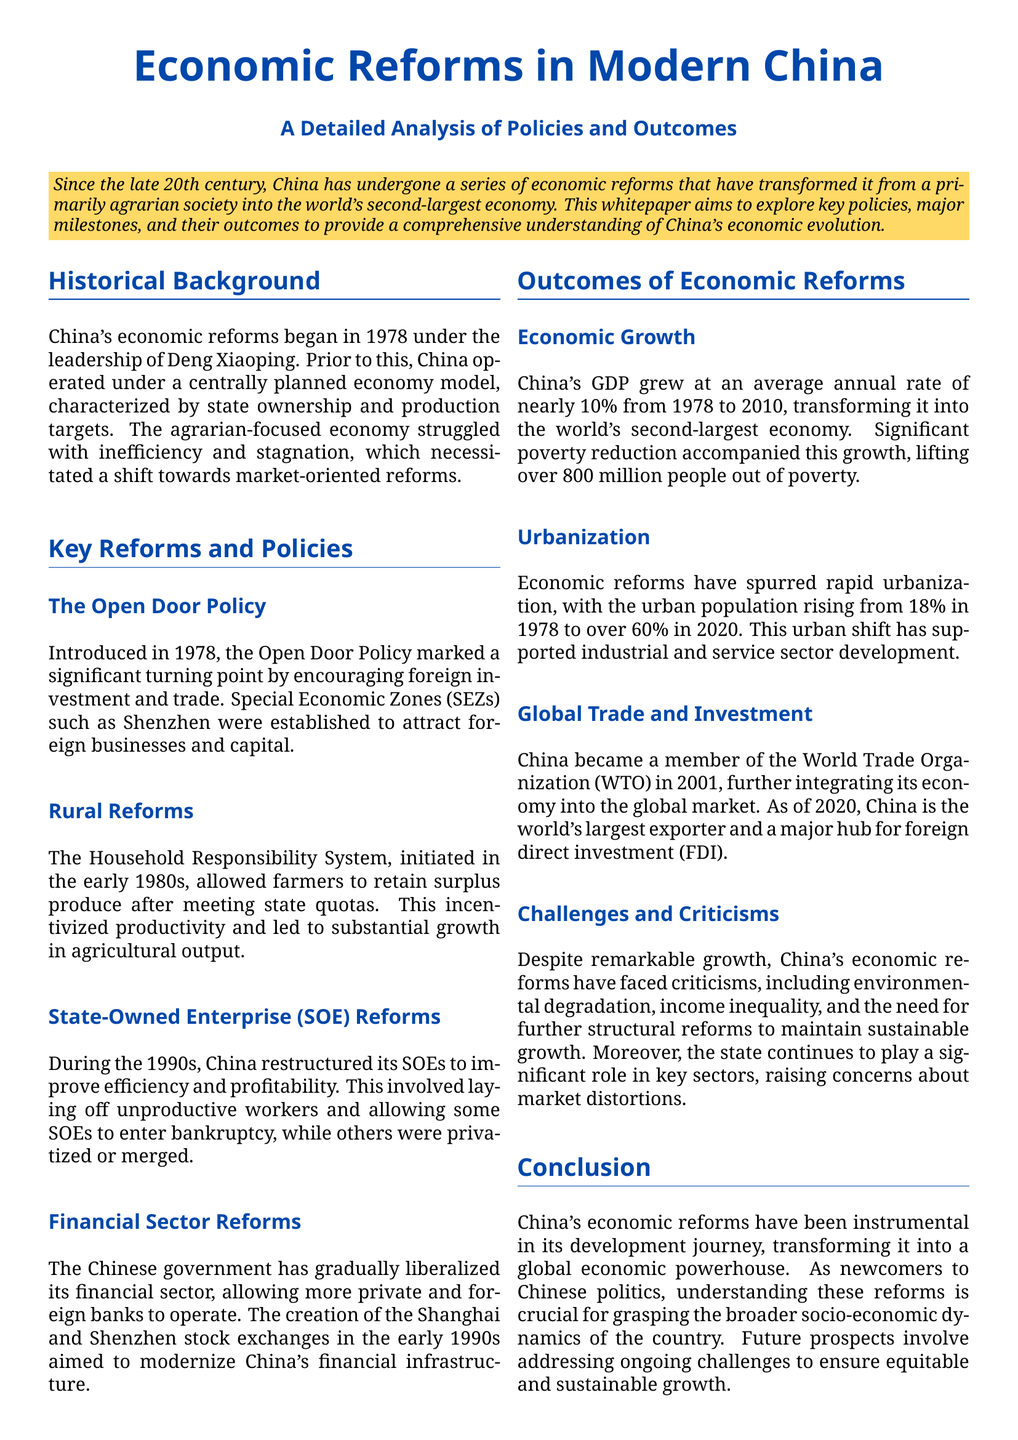What year did China's economic reforms begin? The document states that China's economic reforms began in 1978 under the leadership of Deng Xiaoping.
Answer: 1978 What is the average annual GDP growth rate of China from 1978 to 2010? According to the document, China's GDP grew at an average annual rate of nearly 10% from 1978 to 2010.
Answer: nearly 10% Which policy marked a significant turning point for foreign investment in China? The document mentions that the Open Door Policy introduced in 1978 marked a significant turning point by encouraging foreign investment and trade.
Answer: Open Door Policy How many people were lifted out of poverty due to China's economic growth? The document indicates that over 800 million people were lifted out of poverty as a result of the economic growth in China.
Answer: over 800 million Which two stock exchanges were created to modernize China’s financial infrastructure? The document states that the Shanghai and Shenzhen stock exchanges were created in the early 1990s for this purpose.
Answer: Shanghai and Shenzhen What percentage of the urban population was there in China in 1978? According to the document, the urban population in China was 18% in 1978.
Answer: 18% What major challenge is mentioned regarding China's economic reforms? The document highlights several challenges, including environmental degradation, income inequality, and the need for further structural reforms.
Answer: environmental degradation In what year did China become a member of the World Trade Organization? The document notes that China became a member of the World Trade Organization in 2001.
Answer: 2001 What system incentivized productivity among farmers? The document refers to the Household Responsibility System as the initiative that incentivized productivity among farmers.
Answer: Household Responsibility System 